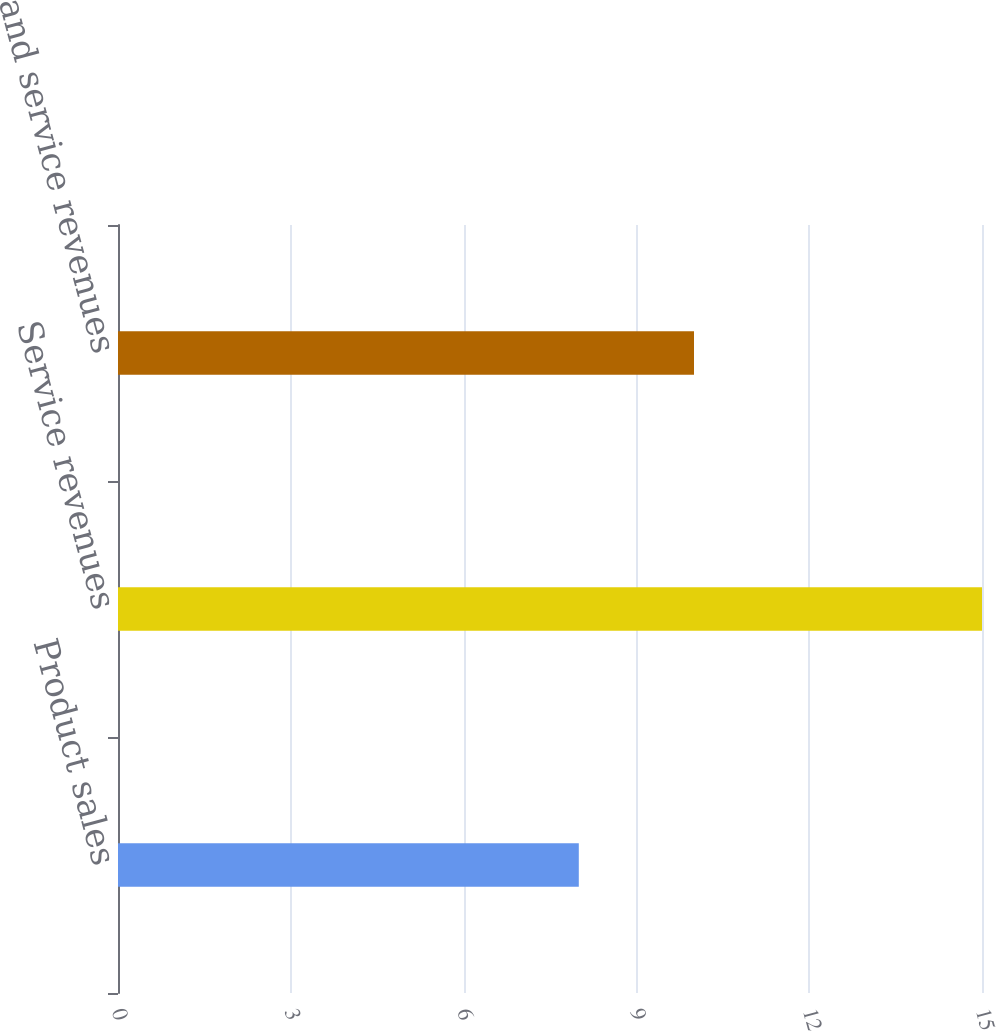Convert chart. <chart><loc_0><loc_0><loc_500><loc_500><bar_chart><fcel>Product sales<fcel>Service revenues<fcel>Sales and service revenues<nl><fcel>8<fcel>15<fcel>10<nl></chart> 